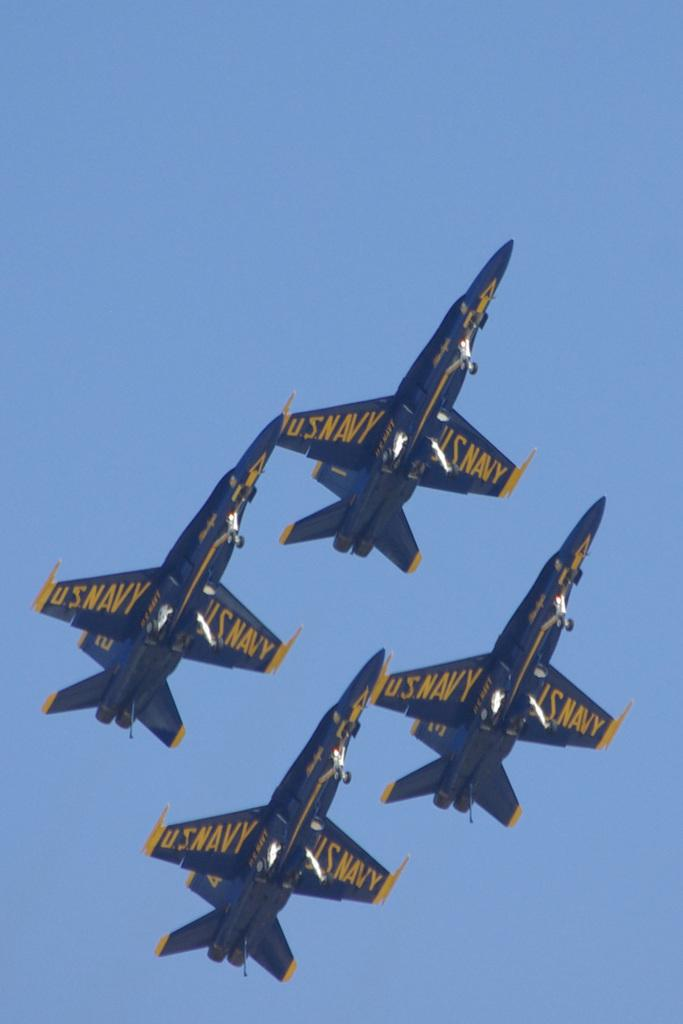Provide a one-sentence caption for the provided image. Four blue and yellow U.S. Navy planes fly in formation. 